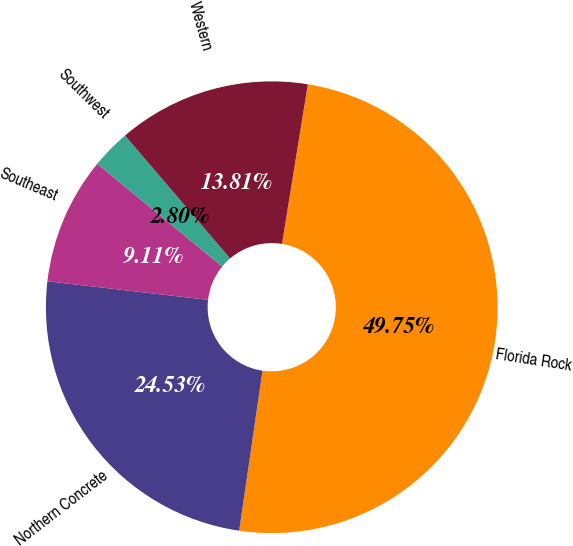<chart> <loc_0><loc_0><loc_500><loc_500><pie_chart><fcel>Florida Rock<fcel>Northern Concrete<fcel>Southeast<fcel>Southwest<fcel>Western<nl><fcel>49.75%<fcel>24.53%<fcel>9.11%<fcel>2.8%<fcel>13.81%<nl></chart> 